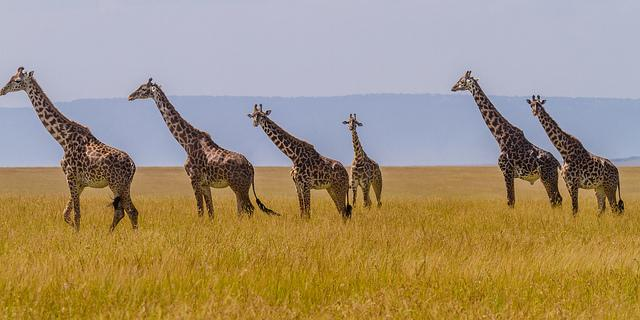How many giraffes are standing up? Please explain your reasoning. six. There are six giraffes standing in the savannah field. 